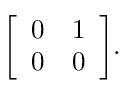<formula> <loc_0><loc_0><loc_500><loc_500>{ \left [ \begin{array} { l l } { 0 } & { 1 } \\ { 0 } & { 0 } \end{array} \right ] } .</formula> 